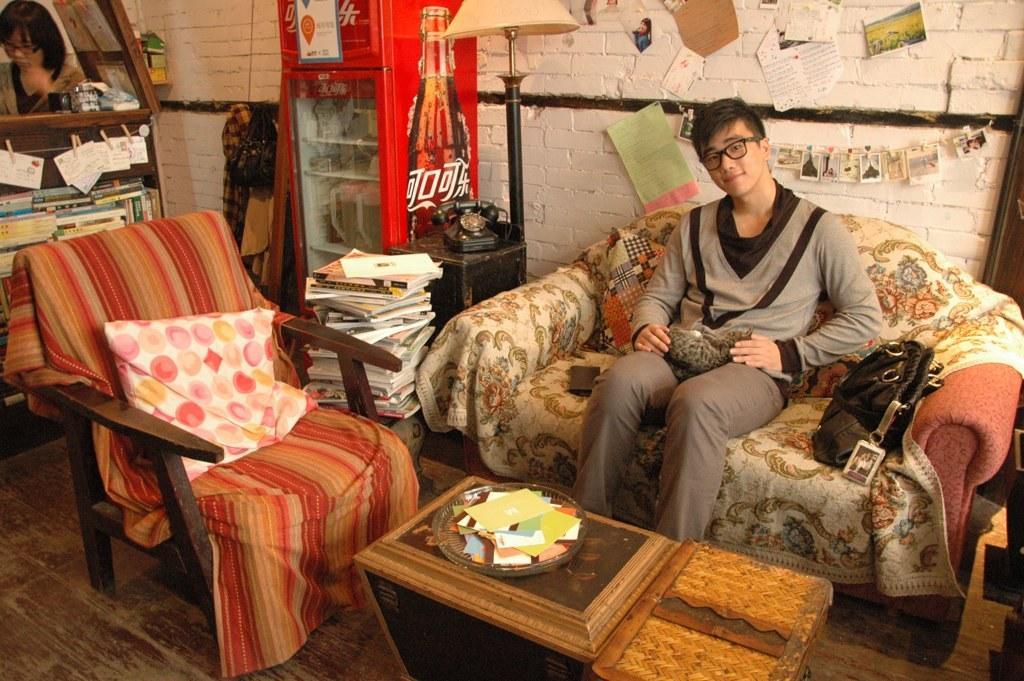Could you give a brief overview of what you see in this image? In this image I see a man, who is sitting on the sofa and there is a chair beside the sofa and there are lot of books over here. I see a table in front and i also see that there is a vending machine over here. In the background I see the wall, few papers on it, clothes, a rack of books and a woman. 